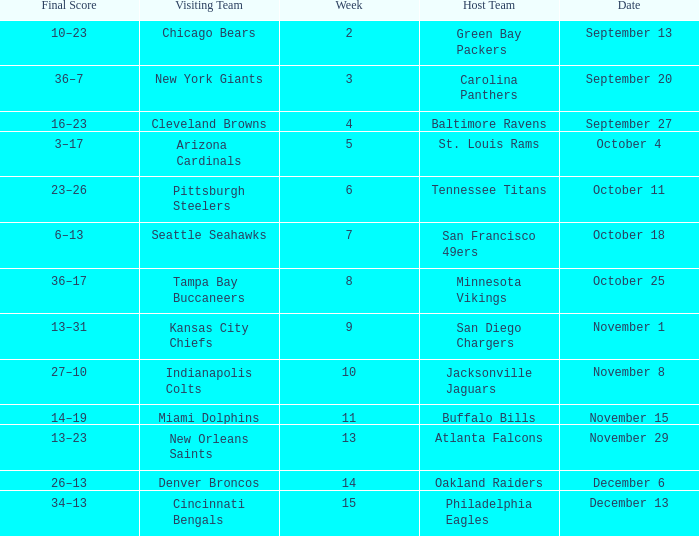What team played on the road against the Buffalo Bills at home ? Miami Dolphins. 